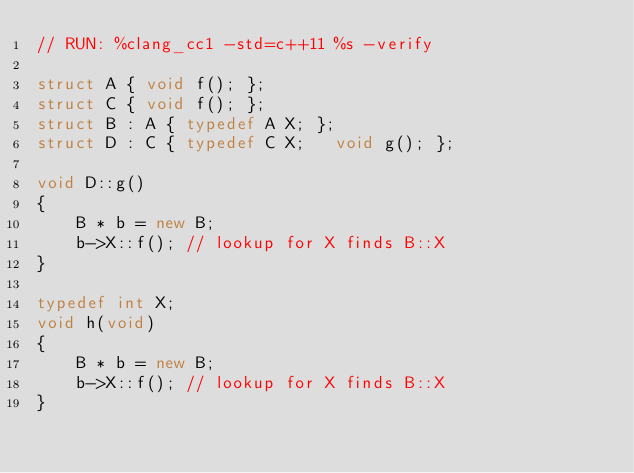Convert code to text. <code><loc_0><loc_0><loc_500><loc_500><_C++_>// RUN: %clang_cc1 -std=c++11 %s -verify

struct A { void f(); };
struct C { void f(); };
struct B : A { typedef A X; };
struct D : C { typedef C X;   void g(); };

void D::g() 
{
    B * b = new B;
    b->X::f(); // lookup for X finds B::X
}

typedef int X;
void h(void) 
{
    B * b = new B;
    b->X::f(); // lookup for X finds B::X
}


</code> 